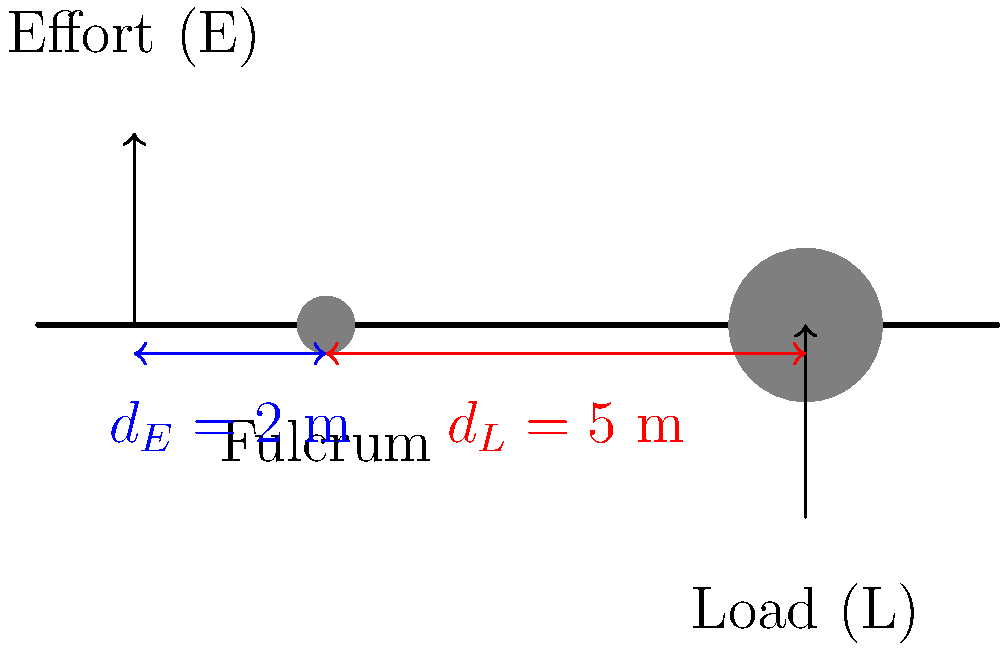A farmer in your village uses a long stick as a lever to lift a heavy rock. The stick is 7 meters long, with the fulcrum placed 2 meters from where the farmer applies the effort. If the rock weighs 250 kg, what is the minimum effort (in Newtons) required to lift the rock? Let's solve this problem step by step:

1) First, we need to understand the principle of levers. The mechanical advantage of a lever is given by the ratio of the load arm to the effort arm:

   $MA = \frac{d_L}{d_E}$

   Where $d_L$ is the distance from the fulcrum to the load, and $d_E$ is the distance from the fulcrum to the effort.

2) From the diagram, we can see that:
   $d_E = 2$ m
   $d_L = 7 - 2 = 5$ m (total length minus effort arm)

3) The mechanical advantage is therefore:
   $MA = \frac{5}{2} = 2.5$

4) The mechanical advantage tells us how many times the effort force is multiplied. In other words:

   $\frac{Load}{Effort} = MA$

5) We know the load is 250 kg. We need to convert this to Newtons:
   $Load = 250 \text{ kg} \times 9.8 \text{ m/s}^2 = 2450 \text{ N}$

6) Now we can set up our equation:
   $\frac{2450 \text{ N}}{Effort} = 2.5$

7) Solving for Effort:
   $Effort = \frac{2450 \text{ N}}{2.5} = 980 \text{ N}$

Therefore, the minimum effort required to lift the rock is 980 N.
Answer: 980 N 